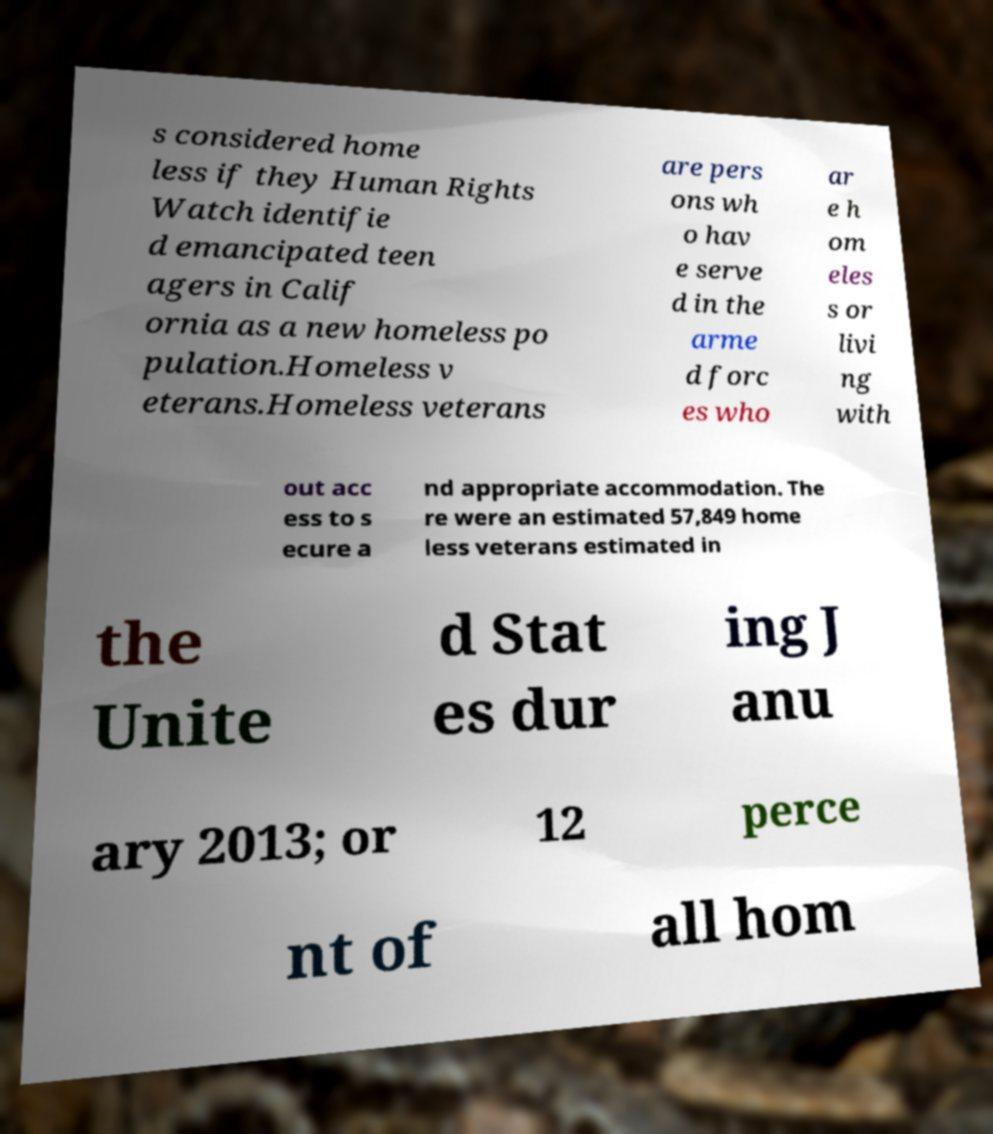Please read and relay the text visible in this image. What does it say? s considered home less if they Human Rights Watch identifie d emancipated teen agers in Calif ornia as a new homeless po pulation.Homeless v eterans.Homeless veterans are pers ons wh o hav e serve d in the arme d forc es who ar e h om eles s or livi ng with out acc ess to s ecure a nd appropriate accommodation. The re were an estimated 57,849 home less veterans estimated in the Unite d Stat es dur ing J anu ary 2013; or 12 perce nt of all hom 